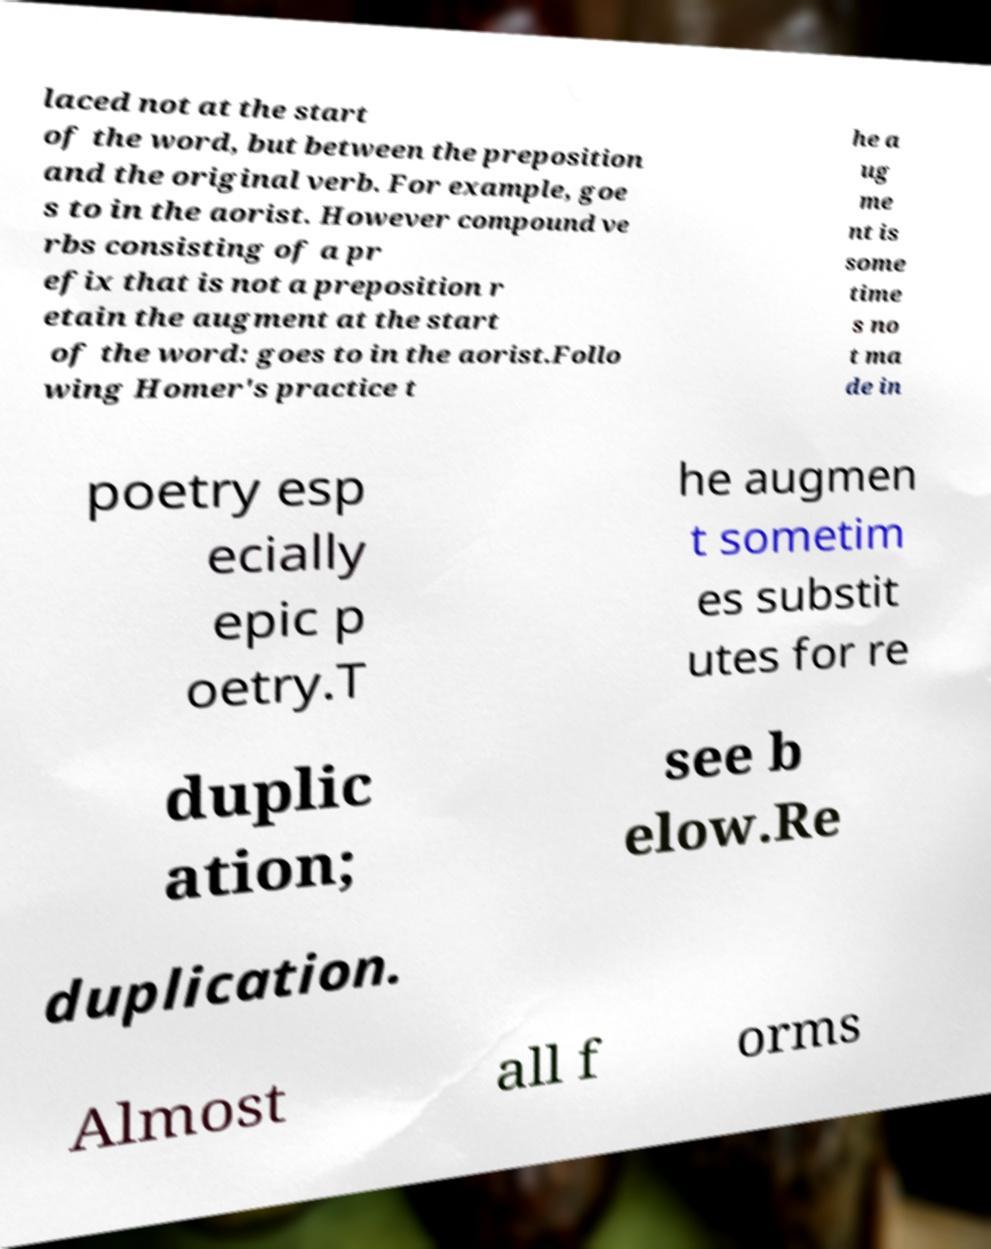Can you read and provide the text displayed in the image?This photo seems to have some interesting text. Can you extract and type it out for me? laced not at the start of the word, but between the preposition and the original verb. For example, goe s to in the aorist. However compound ve rbs consisting of a pr efix that is not a preposition r etain the augment at the start of the word: goes to in the aorist.Follo wing Homer's practice t he a ug me nt is some time s no t ma de in poetry esp ecially epic p oetry.T he augmen t sometim es substit utes for re duplic ation; see b elow.Re duplication. Almost all f orms 